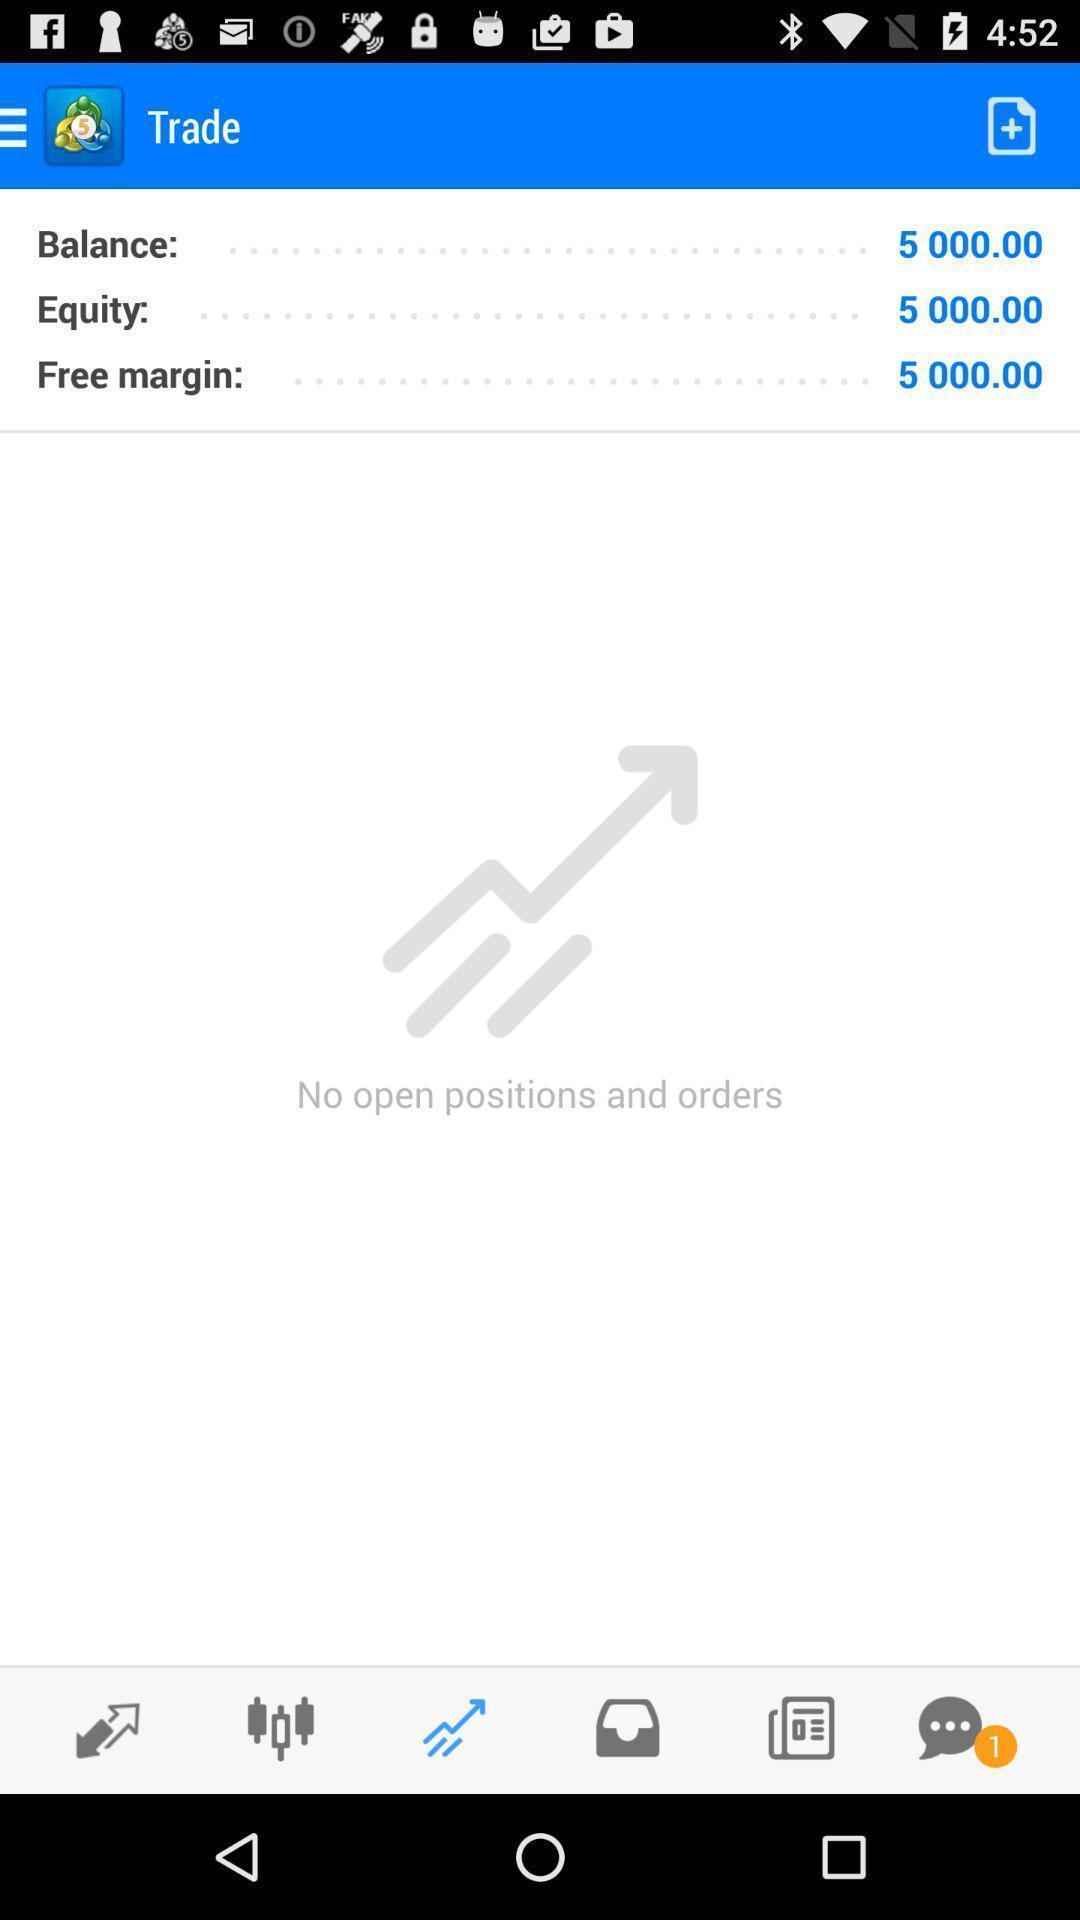Provide a textual representation of this image. Screen shows multiple options in a financial application. 